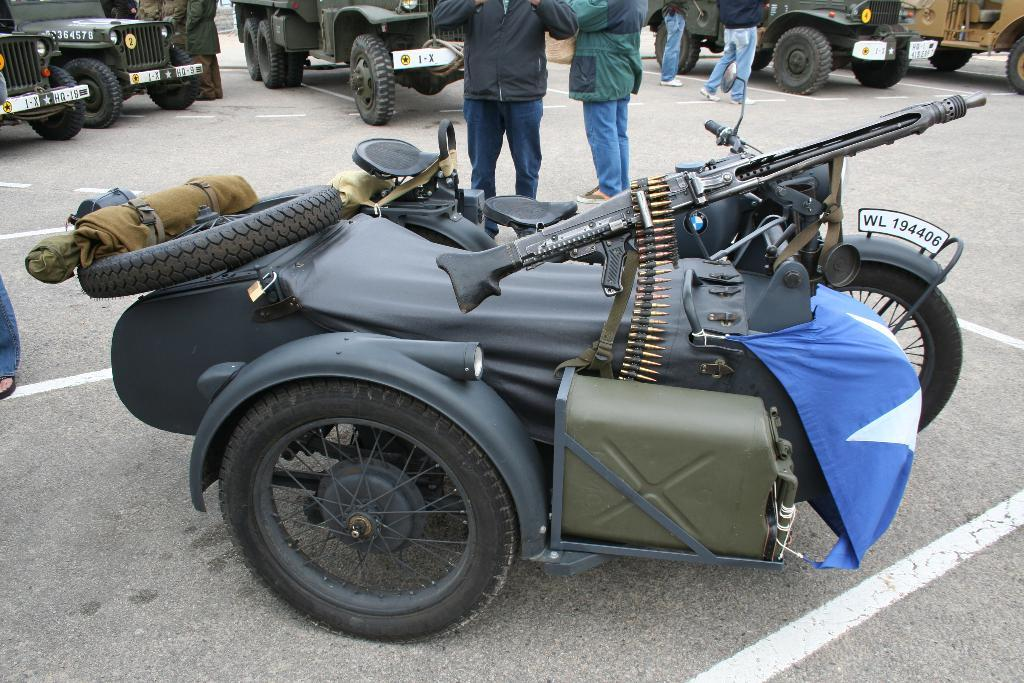What types of objects can be seen in the image? There are vehicles in the image. Are there any living beings present in the image? Yes, there are people on the road in the image. What type of salt can be seen on the road in the image? There is no salt visible on the road in the image. What riddle can be solved by looking at the image? The image does not contain any riddles to be solved. 